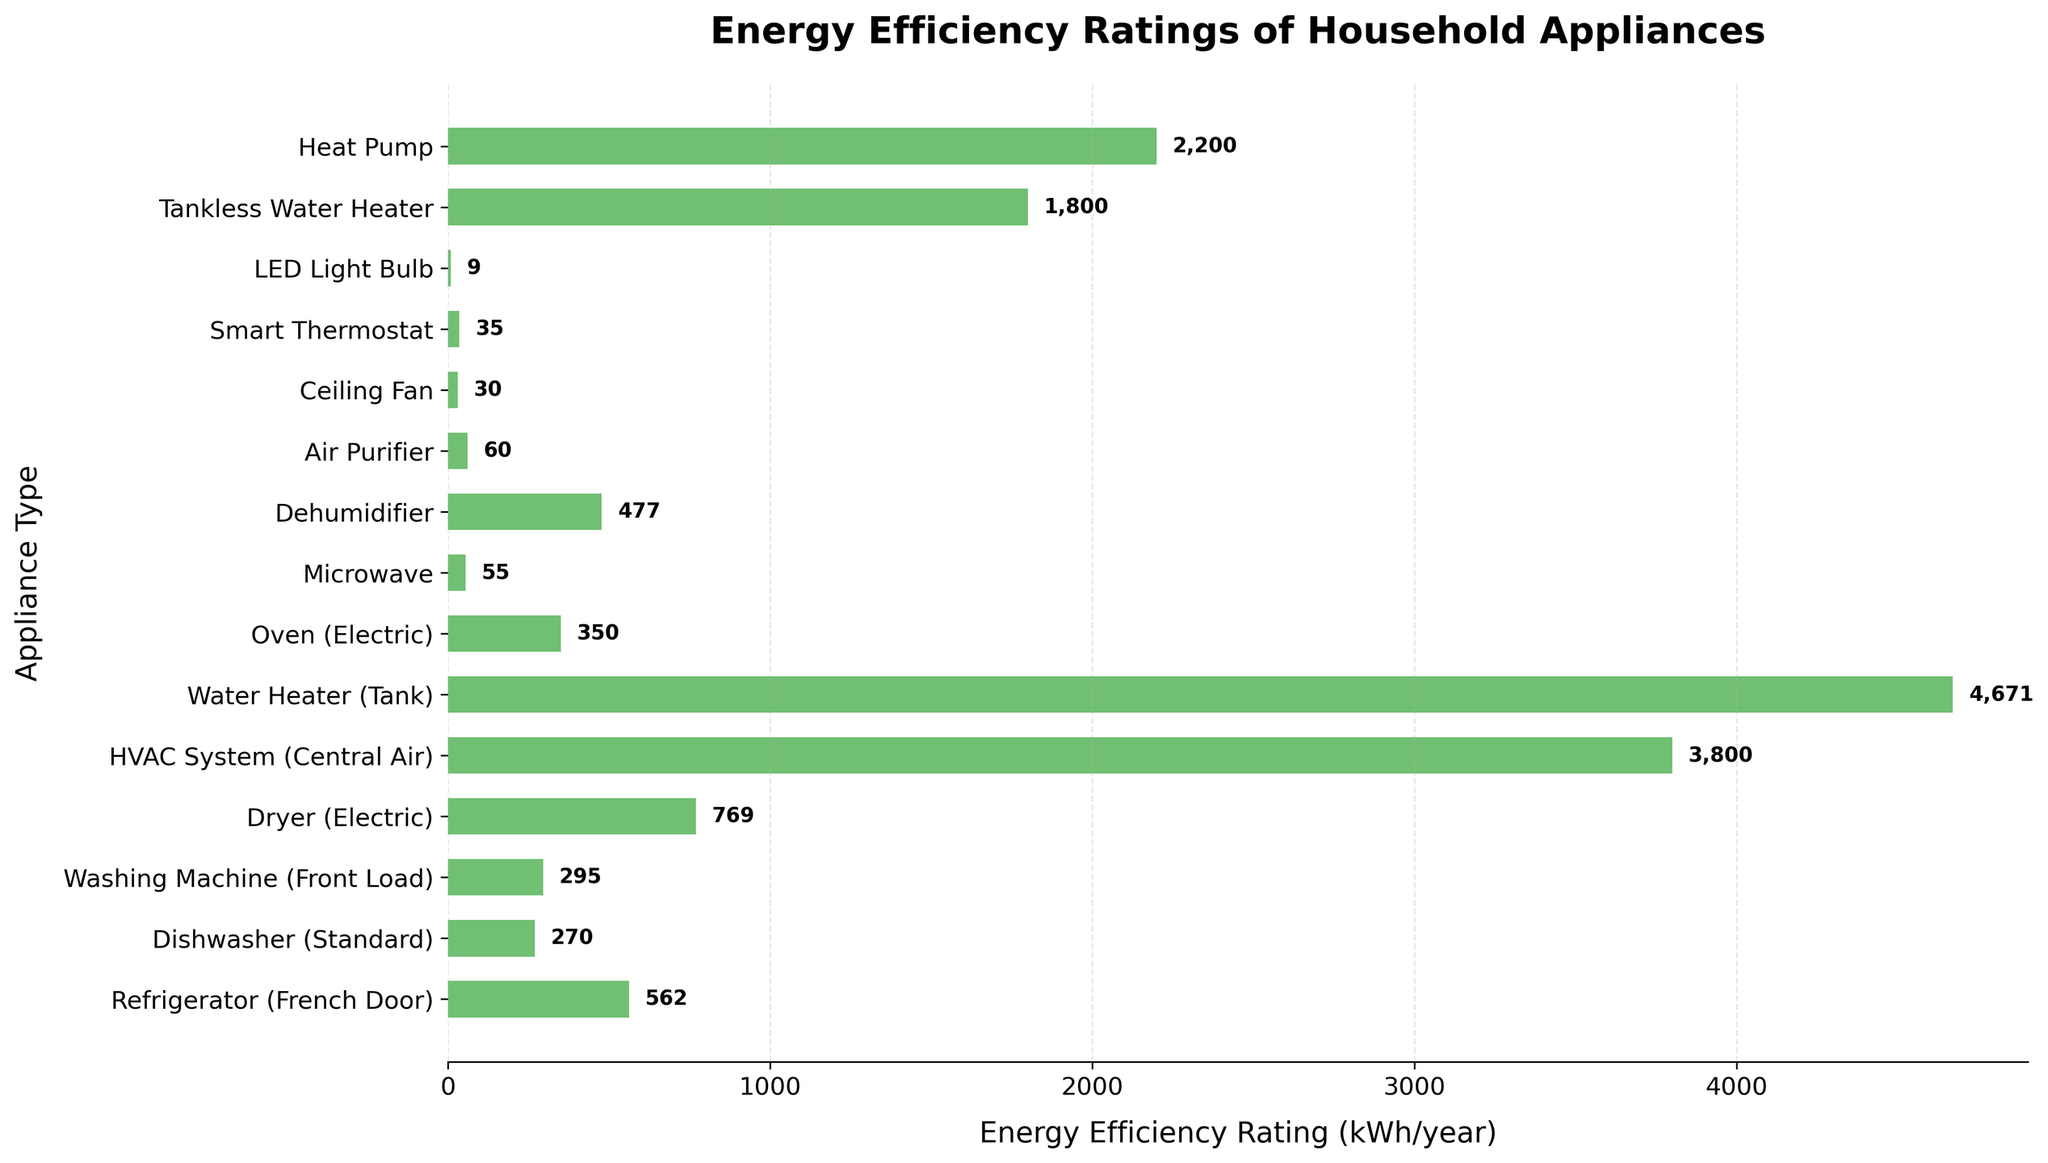Which appliance has the lowest energy efficiency rating? The lowest energy efficiency rating can be identified by finding the shortest bar in the chart, which represents 9 kWh/year for LED Light Bulb.
Answer: LED Light Bulb What is the total energy efficiency rating of the Dryer (Electric) and Refrigerator (French Door)? Add the energy efficiency ratings of the Dryer (769 kWh/year) and the Refrigerator (562 kWh/year). 769 + 562 = 1331.
Answer: 1331 kWh/year Which appliance has the highest energy efficiency rating? The highest energy efficiency rating can be determined by locating the longest bar in the chart, which is 4671 kWh/year for Water Heater (Tank).
Answer: Water Heater (Tank) Which uses more energy: an HVAC System (Central Air) or two Heat Pumps? Compare the energy efficiency ratings: HVAC System (3800 kWh/year) vs. 2 Heat Pumps (2200 kWh/year each): 2200 * 2 = 4400. Since 4400 is greater than 3800, two Heat Pumps use more energy.
Answer: Two Heat Pumps How does the energy efficiency rating of an Air Purifier compare to a Ceiling Fan? Compare the ratings visually on the chart: Air Purifier (60 kWh/year) and Ceiling Fan (30 kWh/year). 60 is greater than 30, so the Air Purifier uses more energy.
Answer: Air Purifier What is the average energy efficiency rating of common household appliances in the chart? Add all the energy efficiency ratings and divide by the number of appliances. Sum = 562 + 270 + 295 + 769 + 3800 + 4671 + 350 + 55 + 477 + 60 + 30 + 35 + 9 + 1800 + 2200 = 14,383. Divide by 15: 14,383 / 15 = 959.
Answer: 959 kWh/year If you were to replace an Oven (Electric) and a Dishwasher (Standard) with a Tankless Water Heater, will it save energy? Add the energy ratings of Oven (350 kWh/year) and Dishwasher (270 kWh/year): 350 + 270 = 620. Compare with Tankless Water Heater (1800 kWh/year). Since 620 is less than 1800, replacing with a Tankless Water Heater will not save energy.
Answer: No What is the difference in the energy efficiency rating between the Appliance with the highest rating and the Appliance with the lowest rating? Subtract the lowest rating (LED Light Bulb, 9 kWh/year) from the highest rating (Water Heater, 4671 kWh/year): 4671 - 9 = 4662.
Answer: 4662 kWh/year Which appliances have an energy efficiency rating below 100 kWh/year? Identify bars in the chart below the 100 kWh/year mark: These are LED Light Bulb (9), Ceiling Fan (30), Smart Thermostat (35), and Air Purifier (60).
Answer: LED Light Bulb, Ceiling Fan, Smart Thermostat, Air Purifier 